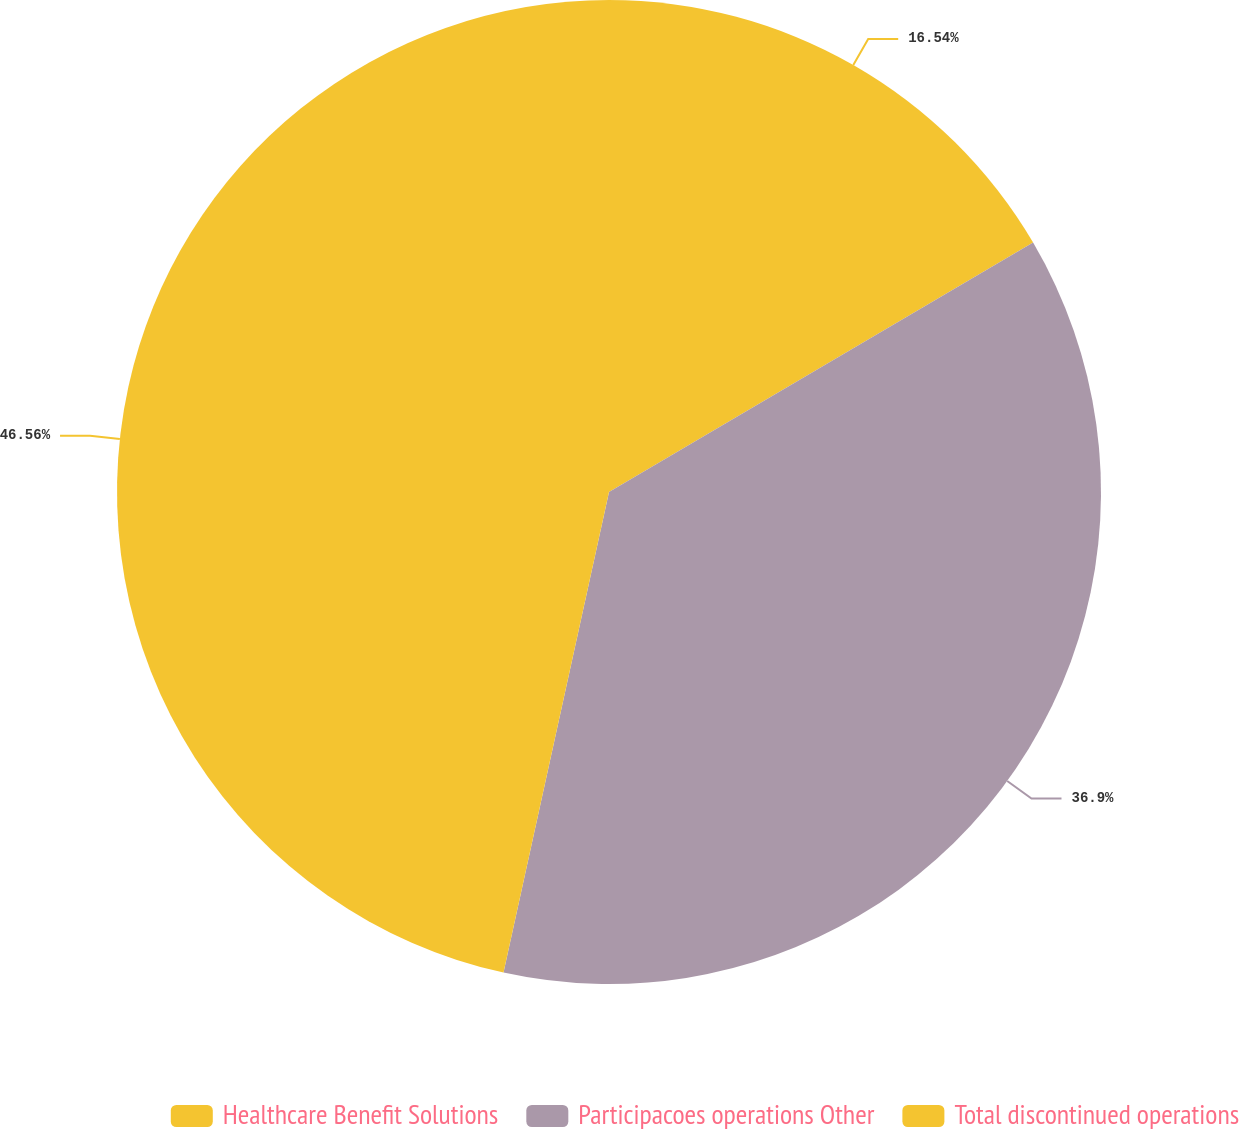Convert chart to OTSL. <chart><loc_0><loc_0><loc_500><loc_500><pie_chart><fcel>Healthcare Benefit Solutions<fcel>Participacoes operations Other<fcel>Total discontinued operations<nl><fcel>16.54%<fcel>36.9%<fcel>46.56%<nl></chart> 